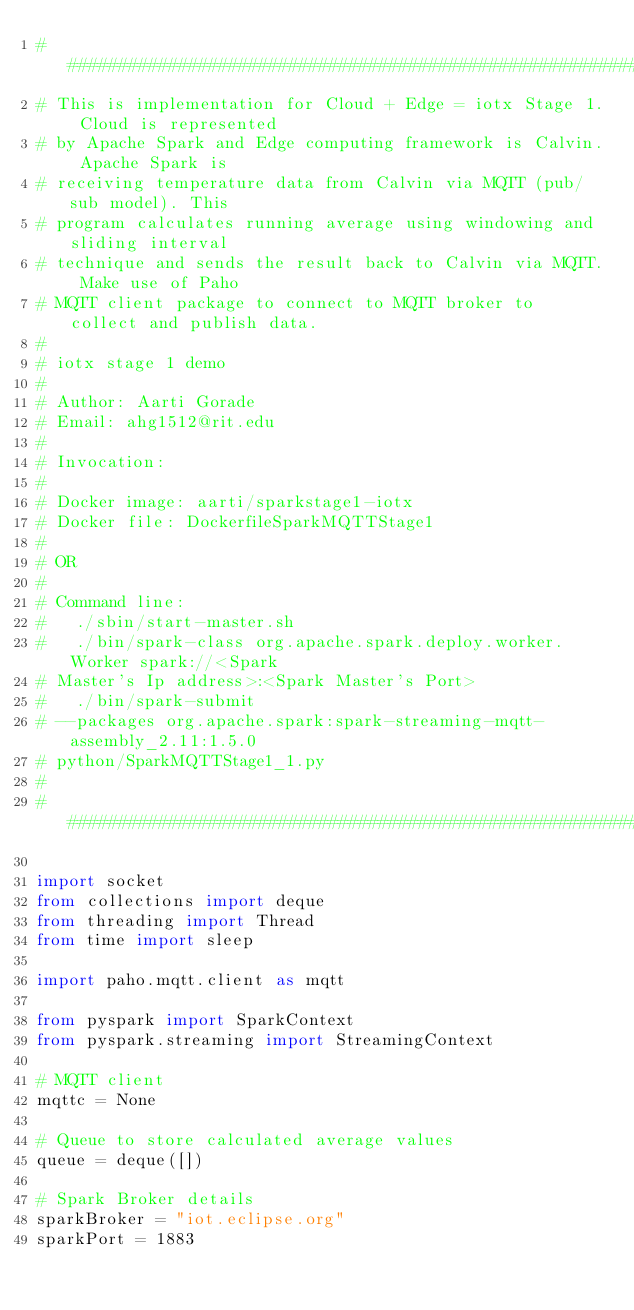Convert code to text. <code><loc_0><loc_0><loc_500><loc_500><_Python_>########################################################################
# This is implementation for Cloud + Edge = iotx Stage 1. Cloud is represented
# by Apache Spark and Edge computing framework is Calvin. Apache Spark is
# receiving temperature data from Calvin via MQTT (pub/sub model). This
# program calculates running average using windowing and sliding interval
# technique and sends the result back to Calvin via MQTT. Make use of Paho
# MQTT client package to connect to MQTT broker to collect and publish data.
#
# iotx stage 1 demo
#
# Author: Aarti Gorade
# Email: ahg1512@rit.edu
#
# Invocation:
#
# Docker image: aarti/sparkstage1-iotx
# Docker file: DockerfileSparkMQTTStage1
#
# OR
#
# Command line:
#   ./sbin/start-master.sh
#   ./bin/spark-class org.apache.spark.deploy.worker.Worker spark://<Spark
# Master's Ip address>:<Spark Master's Port>
#   ./bin/spark-submit
# --packages org.apache.spark:spark-streaming-mqtt-assembly_2.11:1.5.0
# python/SparkMQTTStage1_1.py
#
########################################################################

import socket
from collections import deque
from threading import Thread
from time import sleep

import paho.mqtt.client as mqtt

from pyspark import SparkContext
from pyspark.streaming import StreamingContext

# MQTT client
mqttc = None

# Queue to store calculated average values
queue = deque([])

# Spark Broker details
sparkBroker = "iot.eclipse.org"
sparkPort = 1883</code> 